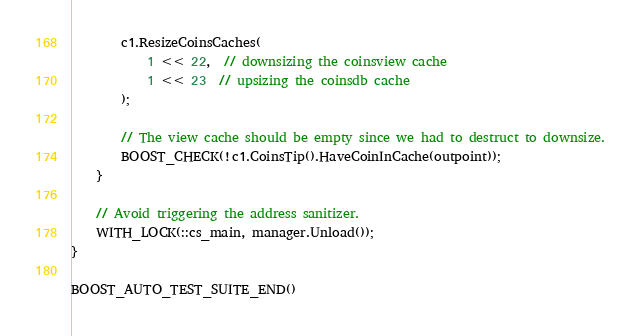<code> <loc_0><loc_0><loc_500><loc_500><_C++_>
        c1.ResizeCoinsCaches(
            1 << 22,  // downsizing the coinsview cache
            1 << 23  // upsizing the coinsdb cache
        );

        // The view cache should be empty since we had to destruct to downsize.
        BOOST_CHECK(!c1.CoinsTip().HaveCoinInCache(outpoint));
    }

    // Avoid triggering the address sanitizer.
    WITH_LOCK(::cs_main, manager.Unload());
}

BOOST_AUTO_TEST_SUITE_END()
</code> 